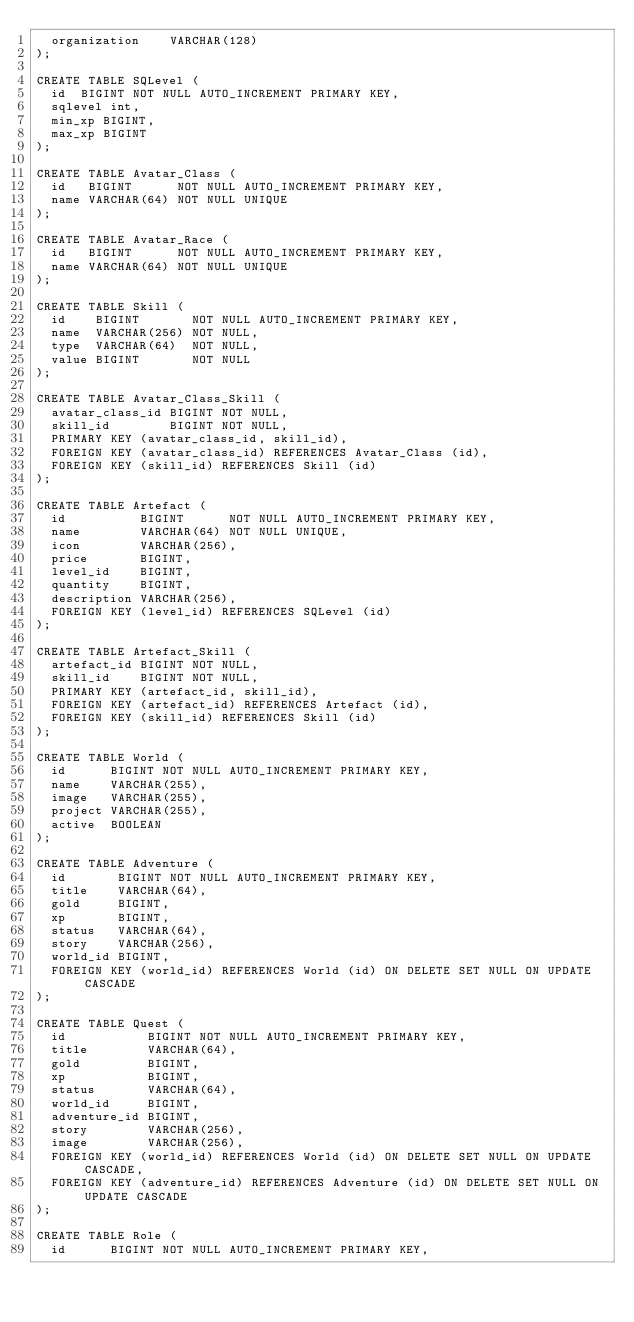Convert code to text. <code><loc_0><loc_0><loc_500><loc_500><_SQL_>  organization		VARCHAR(128)
);

CREATE TABLE SQLevel (
  id  BIGINT NOT NULL AUTO_INCREMENT PRIMARY KEY,
  sqlevel int,
  min_xp BIGINT,
  max_xp BIGINT
);

CREATE TABLE Avatar_Class (
  id   BIGINT      NOT NULL AUTO_INCREMENT PRIMARY KEY,
  name VARCHAR(64) NOT NULL UNIQUE
);

CREATE TABLE Avatar_Race (
  id   BIGINT      NOT NULL AUTO_INCREMENT PRIMARY KEY,
  name VARCHAR(64) NOT NULL UNIQUE
);

CREATE TABLE Skill (
  id    BIGINT       NOT NULL AUTO_INCREMENT PRIMARY KEY,
  name  VARCHAR(256) NOT NULL,
  type  VARCHAR(64)  NOT NULL,
  value BIGINT       NOT NULL
);

CREATE TABLE Avatar_Class_Skill (
  avatar_class_id BIGINT NOT NULL,
  skill_id        BIGINT NOT NULL,
  PRIMARY KEY (avatar_class_id, skill_id),
  FOREIGN KEY (avatar_class_id) REFERENCES Avatar_Class (id),
  FOREIGN KEY (skill_id) REFERENCES Skill (id)
);

CREATE TABLE Artefact (
  id          BIGINT      NOT NULL AUTO_INCREMENT PRIMARY KEY,
  name        VARCHAR(64) NOT NULL UNIQUE,
  icon        VARCHAR(256),
  price       BIGINT,
  level_id    BIGINT,
  quantity    BIGINT,
  description VARCHAR(256),
  FOREIGN KEY (level_id) REFERENCES SQLevel (id)
);

CREATE TABLE Artefact_Skill (
  artefact_id BIGINT NOT NULL,
  skill_id    BIGINT NOT NULL,
  PRIMARY KEY (artefact_id, skill_id),
  FOREIGN KEY (artefact_id) REFERENCES Artefact (id),
  FOREIGN KEY (skill_id) REFERENCES Skill (id)
);

CREATE TABLE World (
  id      BIGINT NOT NULL AUTO_INCREMENT PRIMARY KEY,
  name    VARCHAR(255),
  image   VARCHAR(255),
  project VARCHAR(255),
  active  BOOLEAN
);

CREATE TABLE Adventure (
  id       BIGINT NOT NULL AUTO_INCREMENT PRIMARY KEY,
  title    VARCHAR(64),
  gold     BIGINT,
  xp       BIGINT,
  status   VARCHAR(64),
  story    VARCHAR(256),
  world_id BIGINT,
  FOREIGN KEY (world_id) REFERENCES World (id) ON DELETE SET NULL ON UPDATE CASCADE
);

CREATE TABLE Quest (
  id           BIGINT NOT NULL AUTO_INCREMENT PRIMARY KEY,
  title        VARCHAR(64),
  gold         BIGINT,
  xp           BIGINT,
  status       VARCHAR(64),
  world_id     BIGINT,
  adventure_id BIGINT,
  story        VARCHAR(256),
  image        VARCHAR(256),
  FOREIGN KEY (world_id) REFERENCES World (id) ON DELETE SET NULL ON UPDATE CASCADE,
  FOREIGN KEY (adventure_id) REFERENCES Adventure (id) ON DELETE SET NULL ON UPDATE CASCADE
);

CREATE TABLE Role (
	id			BIGINT NOT NULL AUTO_INCREMENT PRIMARY KEY,</code> 